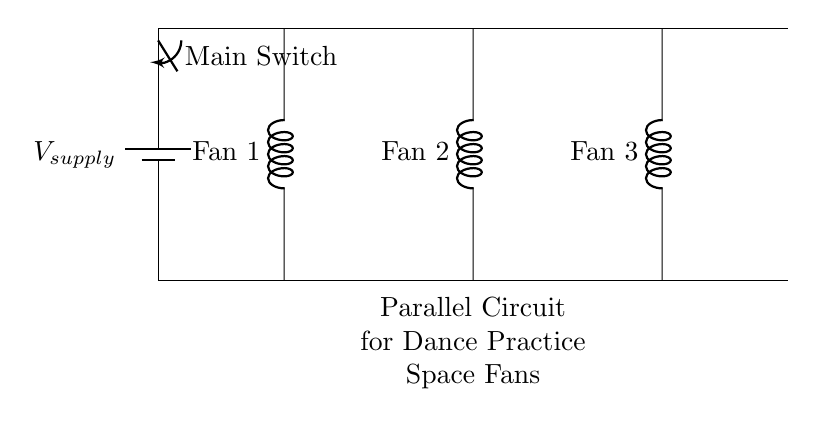What is the total number of fans connected? There are three fans connected in the circuit. Each fan is indicated by a cute inductor symbol, and they are listed as Fan 1, Fan 2, and Fan 3.
Answer: three What does the main switch control? The main switch controls the entire circuit, allowing or preventing the flow of current to the fans. It connects to the supply voltage and cuts off power when open.
Answer: power to fans What type of circuit is shown? The circuit is a parallel circuit, meaning that the components (fans) are connected across the same voltage source independently.
Answer: parallel What is the supply voltage source labeled as? The supply voltage source is labeled as V supply, indicating the voltage provided to the circuit.
Answer: V supply How many main lines are there in this circuit? There are two main lines in the circuit: one for the supply voltage and one for the return path. This allows the current to flow through all components.
Answer: two If one fan fails, what happens to the others? If one fan fails, the others continue to operate normally because each fan is connected in a parallel configuration and operates independently.
Answer: others still work What component provides the voltage for the fans? The component providing the voltage for the fans is the battery, labeled as V supply in the diagram.
Answer: battery 